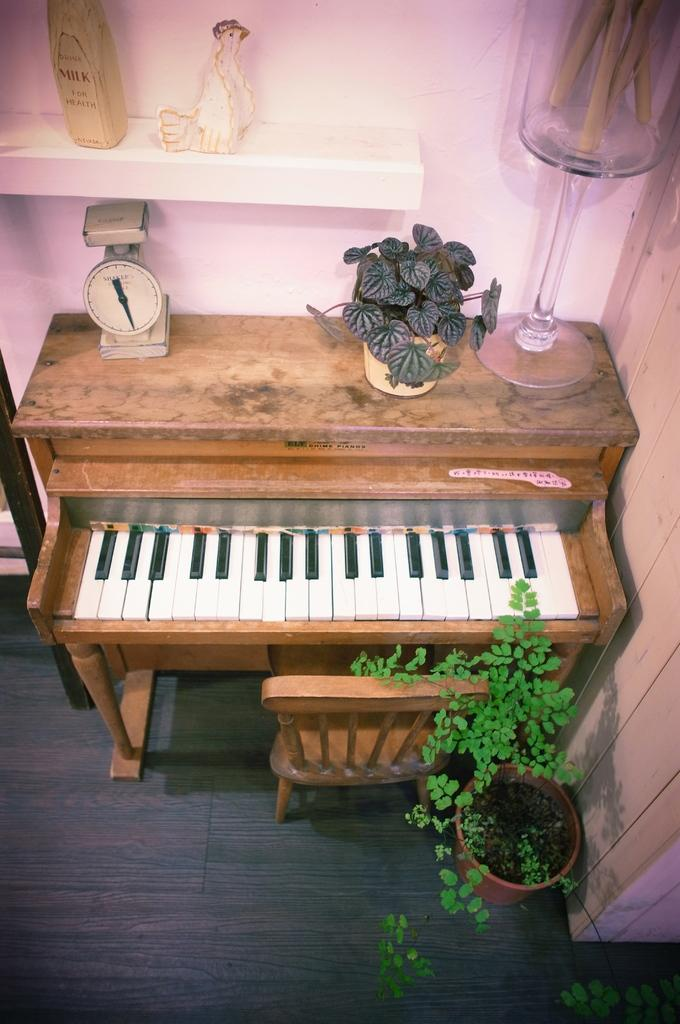What musical instrument is present in the image? There is a piano in the image. What type of furniture is in the image? There is a chair in the image. What kind of greenery is visible in the image? There is a small plant in the image. What additional items can be seen in the image? There are toys in the image. How does the piano affect the throat in the image? The piano does not affect the throat in the image, as it is an inanimate object and not capable of causing any physical effects. 